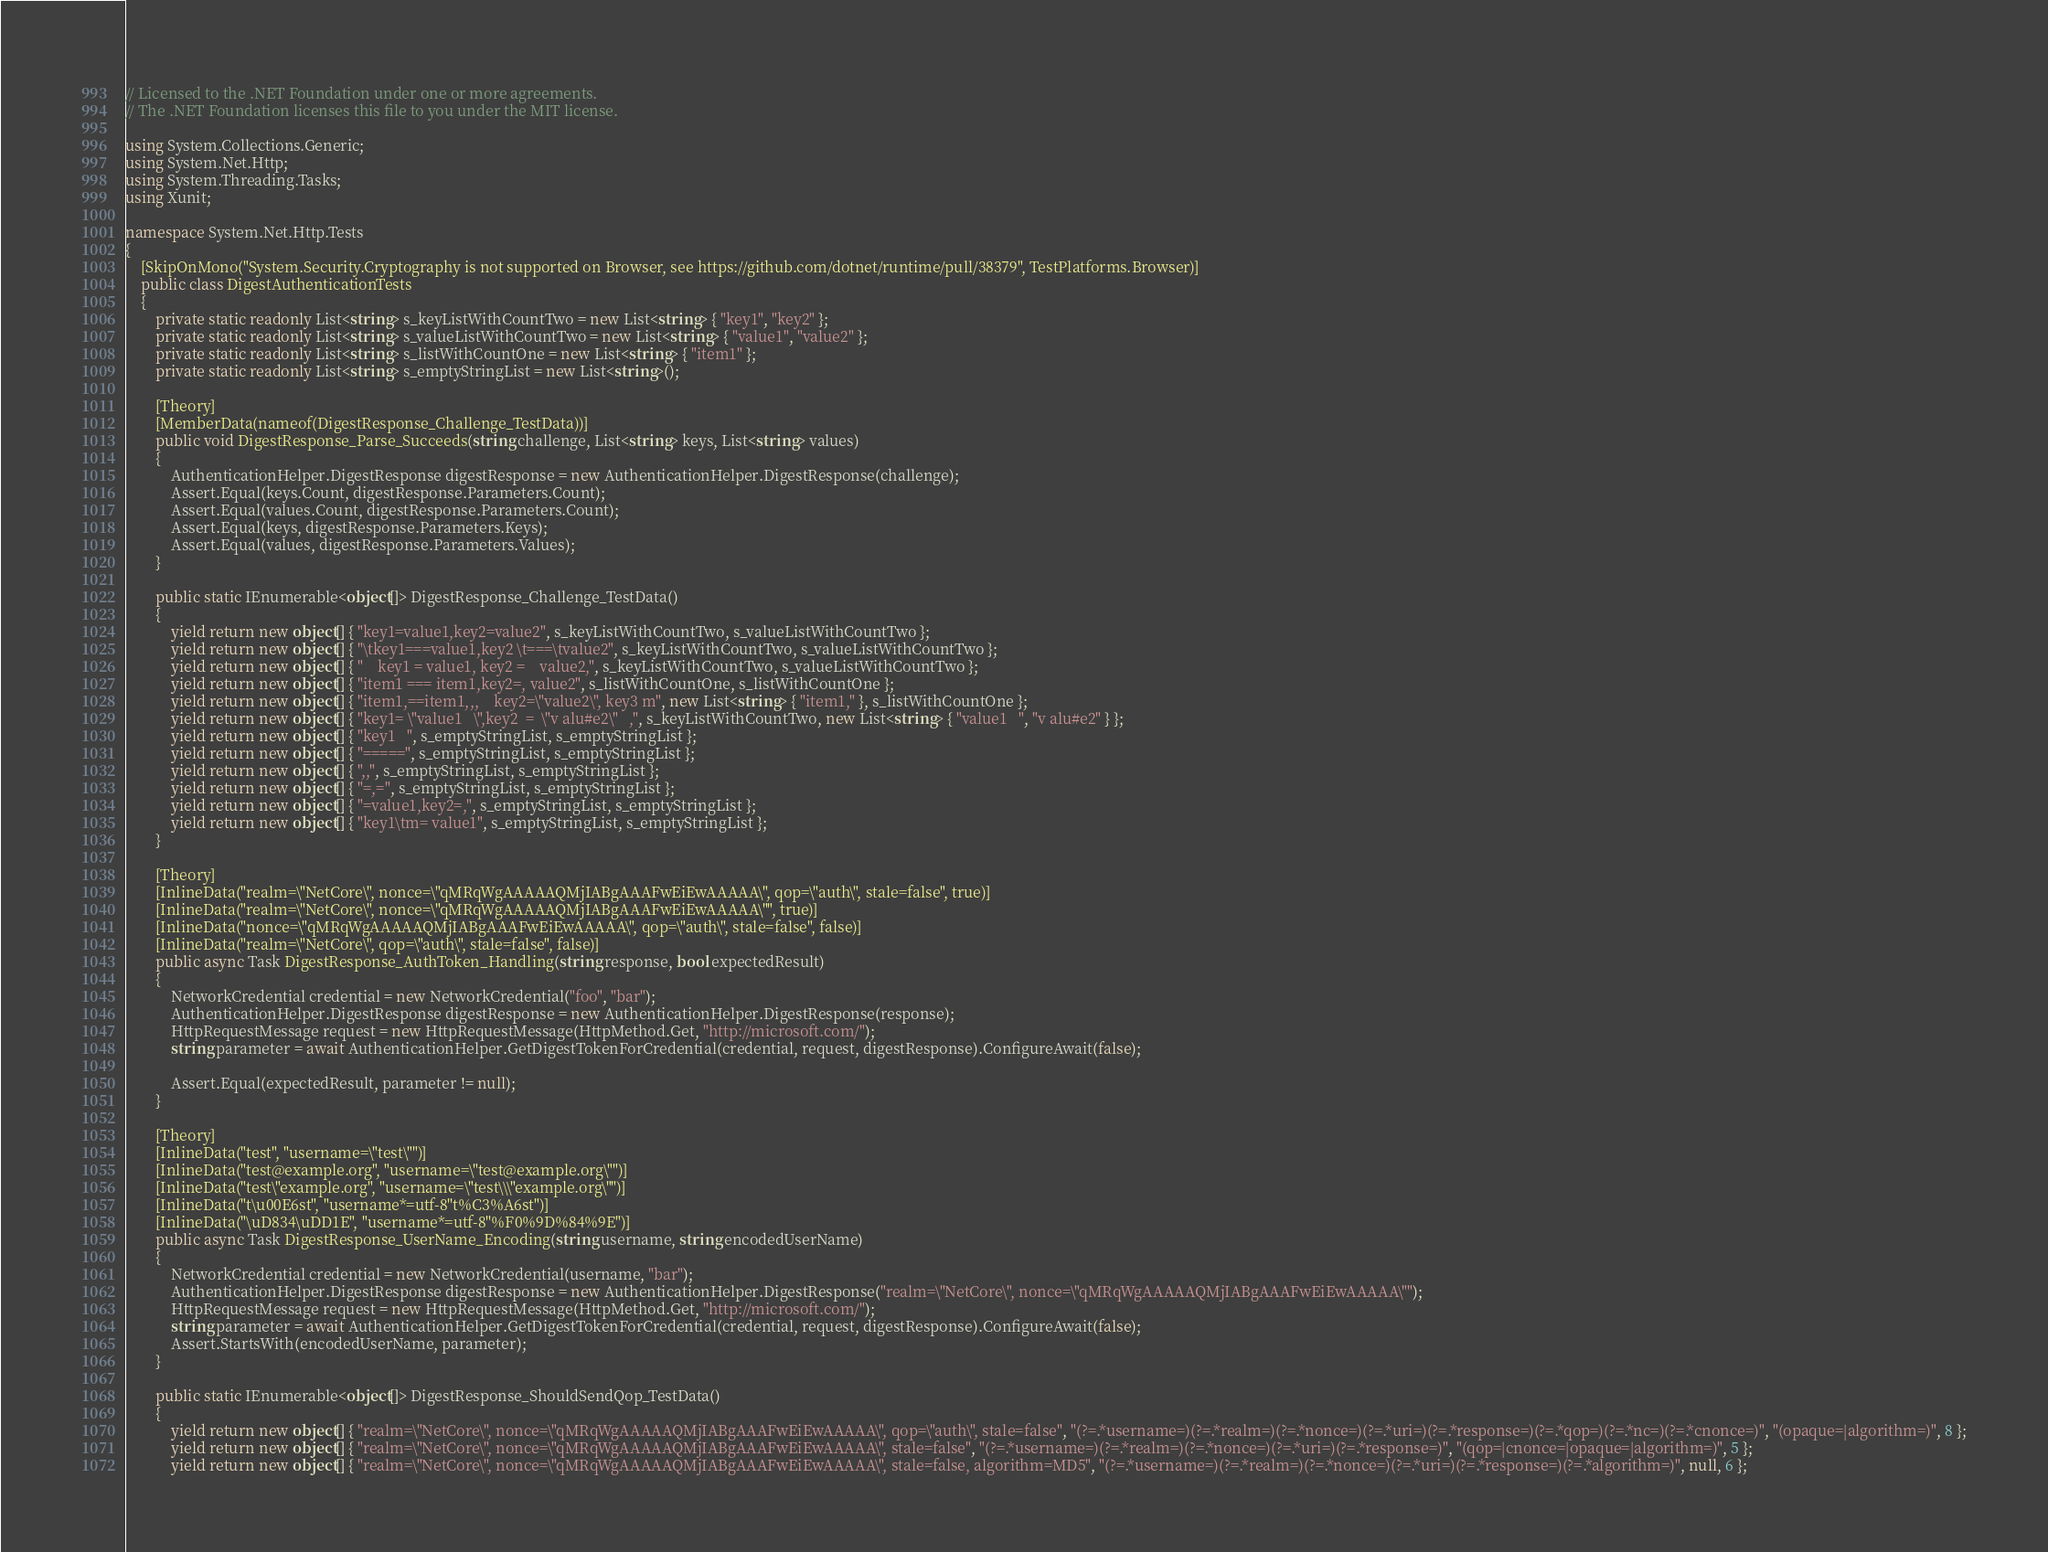<code> <loc_0><loc_0><loc_500><loc_500><_C#_>// Licensed to the .NET Foundation under one or more agreements.
// The .NET Foundation licenses this file to you under the MIT license.

using System.Collections.Generic;
using System.Net.Http;
using System.Threading.Tasks;
using Xunit;

namespace System.Net.Http.Tests
{
    [SkipOnMono("System.Security.Cryptography is not supported on Browser, see https://github.com/dotnet/runtime/pull/38379", TestPlatforms.Browser)]
    public class DigestAuthenticationTests
    {
        private static readonly List<string> s_keyListWithCountTwo = new List<string> { "key1", "key2" };
        private static readonly List<string> s_valueListWithCountTwo = new List<string> { "value1", "value2" };
        private static readonly List<string> s_listWithCountOne = new List<string> { "item1" };
        private static readonly List<string> s_emptyStringList = new List<string>();

        [Theory]
        [MemberData(nameof(DigestResponse_Challenge_TestData))]
        public void DigestResponse_Parse_Succeeds(string challenge, List<string> keys, List<string> values)
        {
            AuthenticationHelper.DigestResponse digestResponse = new AuthenticationHelper.DigestResponse(challenge);
            Assert.Equal(keys.Count, digestResponse.Parameters.Count);
            Assert.Equal(values.Count, digestResponse.Parameters.Count);
            Assert.Equal(keys, digestResponse.Parameters.Keys);
            Assert.Equal(values, digestResponse.Parameters.Values);
        }

        public static IEnumerable<object[]> DigestResponse_Challenge_TestData()
        {
            yield return new object[] { "key1=value1,key2=value2", s_keyListWithCountTwo, s_valueListWithCountTwo };
            yield return new object[] { "\tkey1===value1,key2 \t===\tvalue2", s_keyListWithCountTwo, s_valueListWithCountTwo };
            yield return new object[] { "    key1 = value1, key2 =    value2,", s_keyListWithCountTwo, s_valueListWithCountTwo };
            yield return new object[] { "item1 === item1,key2=, value2", s_listWithCountOne, s_listWithCountOne };
            yield return new object[] { "item1,==item1,,,    key2=\"value2\", key3 m", new List<string> { "item1," }, s_listWithCountOne };
            yield return new object[] { "key1= \"value1   \",key2  =  \"v alu#e2\"   ,", s_keyListWithCountTwo, new List<string> { "value1   ", "v alu#e2" } };
            yield return new object[] { "key1   ", s_emptyStringList, s_emptyStringList };
            yield return new object[] { "=====", s_emptyStringList, s_emptyStringList };
            yield return new object[] { ",,", s_emptyStringList, s_emptyStringList };
            yield return new object[] { "=,=", s_emptyStringList, s_emptyStringList };
            yield return new object[] { "=value1,key2=,", s_emptyStringList, s_emptyStringList };
            yield return new object[] { "key1\tm= value1", s_emptyStringList, s_emptyStringList };
        }

        [Theory]
        [InlineData("realm=\"NetCore\", nonce=\"qMRqWgAAAAAQMjIABgAAAFwEiEwAAAAA\", qop=\"auth\", stale=false", true)]
        [InlineData("realm=\"NetCore\", nonce=\"qMRqWgAAAAAQMjIABgAAAFwEiEwAAAAA\"", true)]
        [InlineData("nonce=\"qMRqWgAAAAAQMjIABgAAAFwEiEwAAAAA\", qop=\"auth\", stale=false", false)]
        [InlineData("realm=\"NetCore\", qop=\"auth\", stale=false", false)]
        public async Task DigestResponse_AuthToken_Handling(string response, bool expectedResult)
        {
            NetworkCredential credential = new NetworkCredential("foo", "bar");
            AuthenticationHelper.DigestResponse digestResponse = new AuthenticationHelper.DigestResponse(response);
            HttpRequestMessage request = new HttpRequestMessage(HttpMethod.Get, "http://microsoft.com/");
            string parameter = await AuthenticationHelper.GetDigestTokenForCredential(credential, request, digestResponse).ConfigureAwait(false);

            Assert.Equal(expectedResult, parameter != null);
        }

        [Theory]
        [InlineData("test", "username=\"test\"")]
        [InlineData("test@example.org", "username=\"test@example.org\"")]
        [InlineData("test\"example.org", "username=\"test\\\"example.org\"")]
        [InlineData("t\u00E6st", "username*=utf-8''t%C3%A6st")]
        [InlineData("\uD834\uDD1E", "username*=utf-8''%F0%9D%84%9E")]
        public async Task DigestResponse_UserName_Encoding(string username, string encodedUserName)
        {
            NetworkCredential credential = new NetworkCredential(username, "bar");
            AuthenticationHelper.DigestResponse digestResponse = new AuthenticationHelper.DigestResponse("realm=\"NetCore\", nonce=\"qMRqWgAAAAAQMjIABgAAAFwEiEwAAAAA\"");
            HttpRequestMessage request = new HttpRequestMessage(HttpMethod.Get, "http://microsoft.com/");
            string parameter = await AuthenticationHelper.GetDigestTokenForCredential(credential, request, digestResponse).ConfigureAwait(false);
            Assert.StartsWith(encodedUserName, parameter);
        }

        public static IEnumerable<object[]> DigestResponse_ShouldSendQop_TestData()
        {
            yield return new object[] { "realm=\"NetCore\", nonce=\"qMRqWgAAAAAQMjIABgAAAFwEiEwAAAAA\", qop=\"auth\", stale=false", "(?=.*username=)(?=.*realm=)(?=.*nonce=)(?=.*uri=)(?=.*response=)(?=.*qop=)(?=.*nc=)(?=.*cnonce=)", "(opaque=|algorithm=)", 8 };
            yield return new object[] { "realm=\"NetCore\", nonce=\"qMRqWgAAAAAQMjIABgAAAFwEiEwAAAAA\", stale=false", "(?=.*username=)(?=.*realm=)(?=.*nonce=)(?=.*uri=)(?=.*response=)", "(qop=|cnonce=|opaque=|algorithm=)", 5 };
            yield return new object[] { "realm=\"NetCore\", nonce=\"qMRqWgAAAAAQMjIABgAAAFwEiEwAAAAA\", stale=false, algorithm=MD5", "(?=.*username=)(?=.*realm=)(?=.*nonce=)(?=.*uri=)(?=.*response=)(?=.*algorithm=)", null, 6 };</code> 